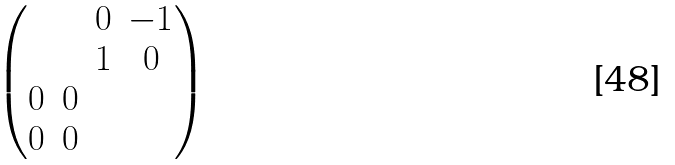Convert formula to latex. <formula><loc_0><loc_0><loc_500><loc_500>\begin{pmatrix} & & 0 & - 1 \\ & & 1 & 0 \\ 0 & 0 & \\ 0 & 0 & \end{pmatrix}</formula> 